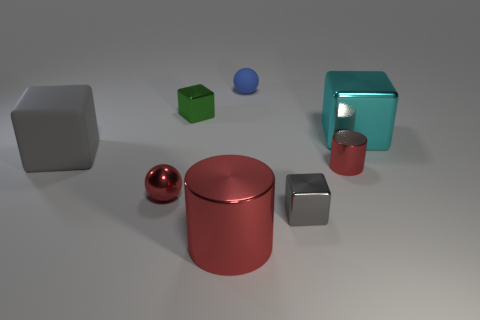Are there more matte cubes to the right of the small green metallic block than yellow metal things?
Ensure brevity in your answer.  No. What color is the rubber thing behind the thing that is on the left side of the sphere that is in front of the small red cylinder?
Give a very brief answer. Blue. Is the material of the large cyan thing the same as the large red object?
Offer a very short reply. Yes. Is there a red metallic cylinder that has the same size as the cyan object?
Provide a short and direct response. Yes. There is a blue object that is the same size as the red ball; what material is it?
Offer a terse response. Rubber. Is there a large gray matte thing that has the same shape as the cyan metallic thing?
Offer a terse response. Yes. What material is the tiny object that is the same color as the rubber cube?
Give a very brief answer. Metal. There is a tiny red metal object that is on the right side of the tiny blue thing; what shape is it?
Provide a short and direct response. Cylinder. How many small gray matte blocks are there?
Ensure brevity in your answer.  0. What color is the other cylinder that is the same material as the big cylinder?
Keep it short and to the point. Red. 